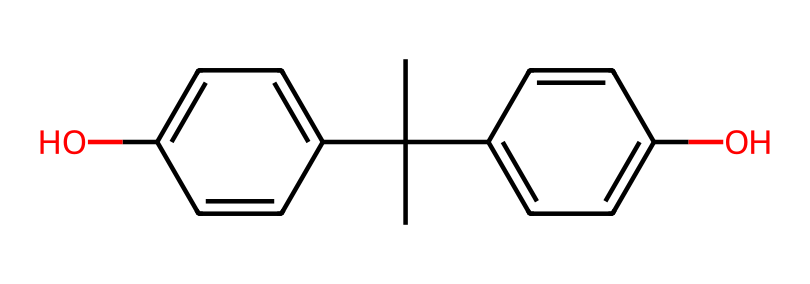how many aromatic rings are present in this compound? The structure contains two benzene rings, as indicated by the presence of two distinct sets of conjugated double bonds. Each benzene ring exhibits aromaticity due to the delocalized π electrons within the cyclic structure.
Answer: 2 what is the molecular formula of bisphenol A? By counting the carbon atoms (12), hydrogen atoms (10), and oxygen atoms (2) present in the structure, the molecular formula can be derived as C12H10O2.
Answer: C12H10O2 does bisphenol A contain any functional groups? The presence of hydroxyl groups (-OH) is indicated by the two locations of bonded oxygen connected to hydrogen atoms in the structure, making them functional groups.
Answer: hydroxyl what is the total number of carbon atoms in bisphenol A? By counting the carbon atoms in the chemical structure, we find there are 12 carbon atoms in total. This includes all carbons in both the aromatic rings and the central tertiary carbon.
Answer: 12 what type of chemical compound is bisphenol A classified as? Given its structure, which comprises multiple aromatic systems and functional groups, bisphenol A is classified as an aromatic compound due to the presence of aromatic rings, specifically phenols.
Answer: phenolic how many hydrogen atoms are directly attached to carbon atoms in bisphenol A? By examining the molecular structure, we can identify that there are 10 hydrogen atoms directly connected to the carbon atoms in the entire compound, including those on the aromatic rings and the aliphatic carbon.
Answer: 10 what is the significance of the hydroxyl groups in bisphenol A? The hydroxyl groups contribute to the properties of bisphenol A, such as increased polarity and hydrogen bonding capabilities, which are crucial for its applications in plastics and its reactivity in various chemical processes.
Answer: reactivity 